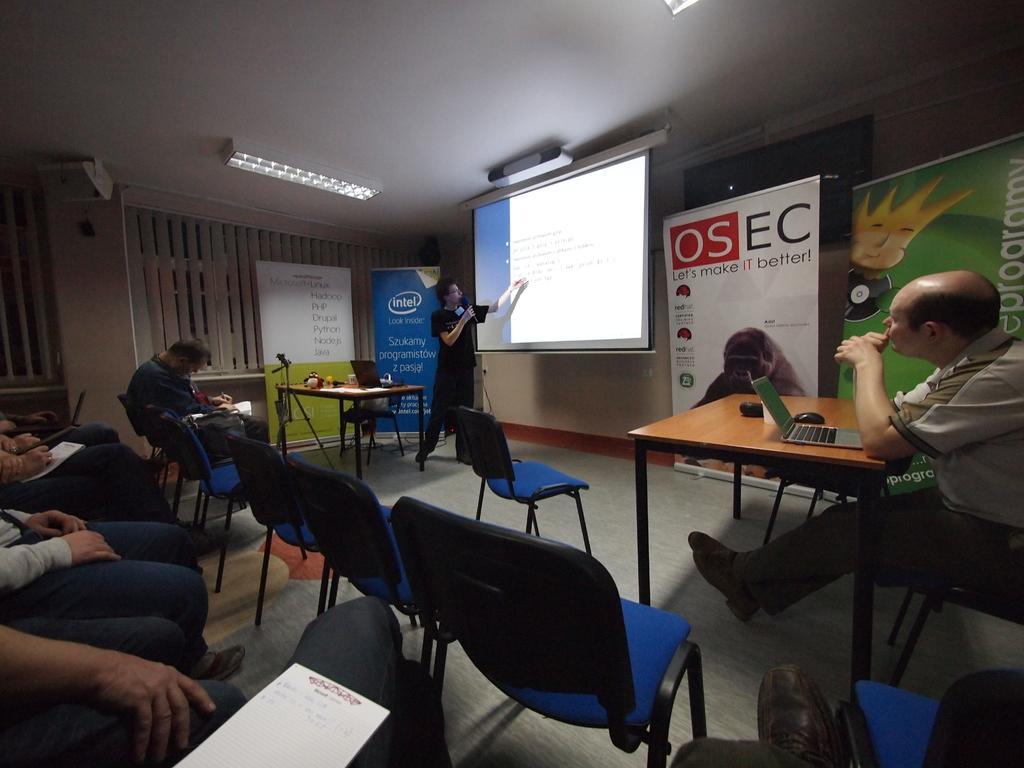In one or two sentences, can you explain what this image depicts? The image is taken in the room. On the right there is a man sitting on the chair. There is a table before him. In the center of the image there is a screen we can also see a man explaining. In the background there are many boards. On the left there are many people sitting on the chairs. At the top there are lights. 